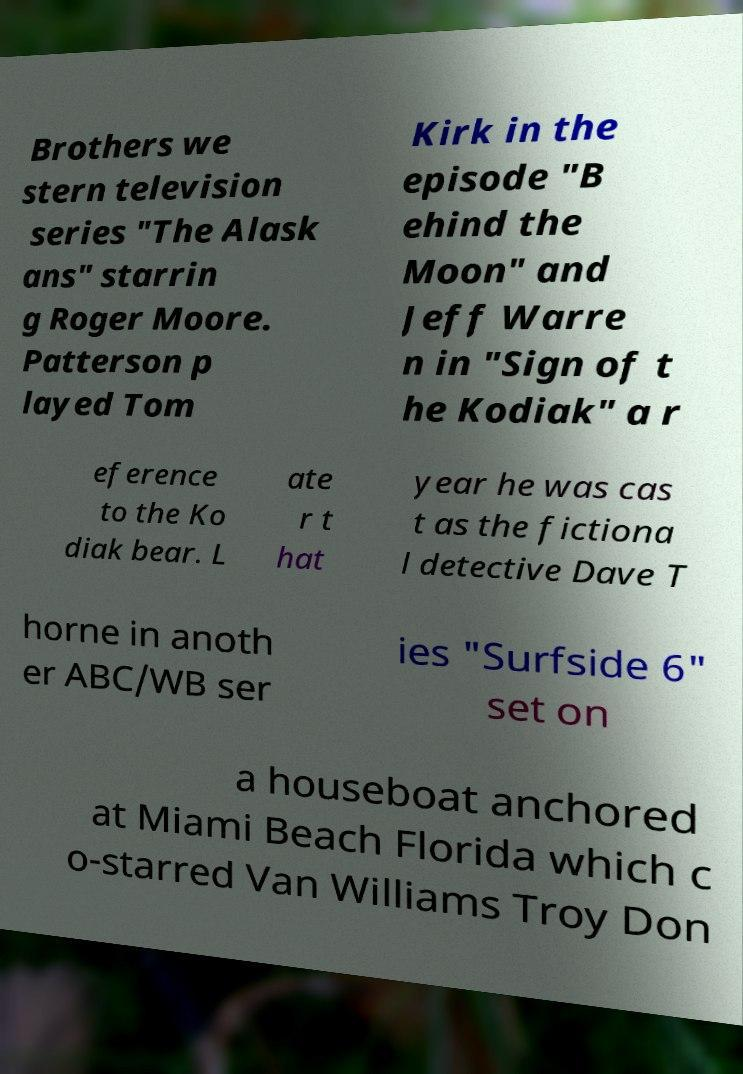For documentation purposes, I need the text within this image transcribed. Could you provide that? Brothers we stern television series "The Alask ans" starrin g Roger Moore. Patterson p layed Tom Kirk in the episode "B ehind the Moon" and Jeff Warre n in "Sign of t he Kodiak" a r eference to the Ko diak bear. L ate r t hat year he was cas t as the fictiona l detective Dave T horne in anoth er ABC/WB ser ies "Surfside 6" set on a houseboat anchored at Miami Beach Florida which c o-starred Van Williams Troy Don 